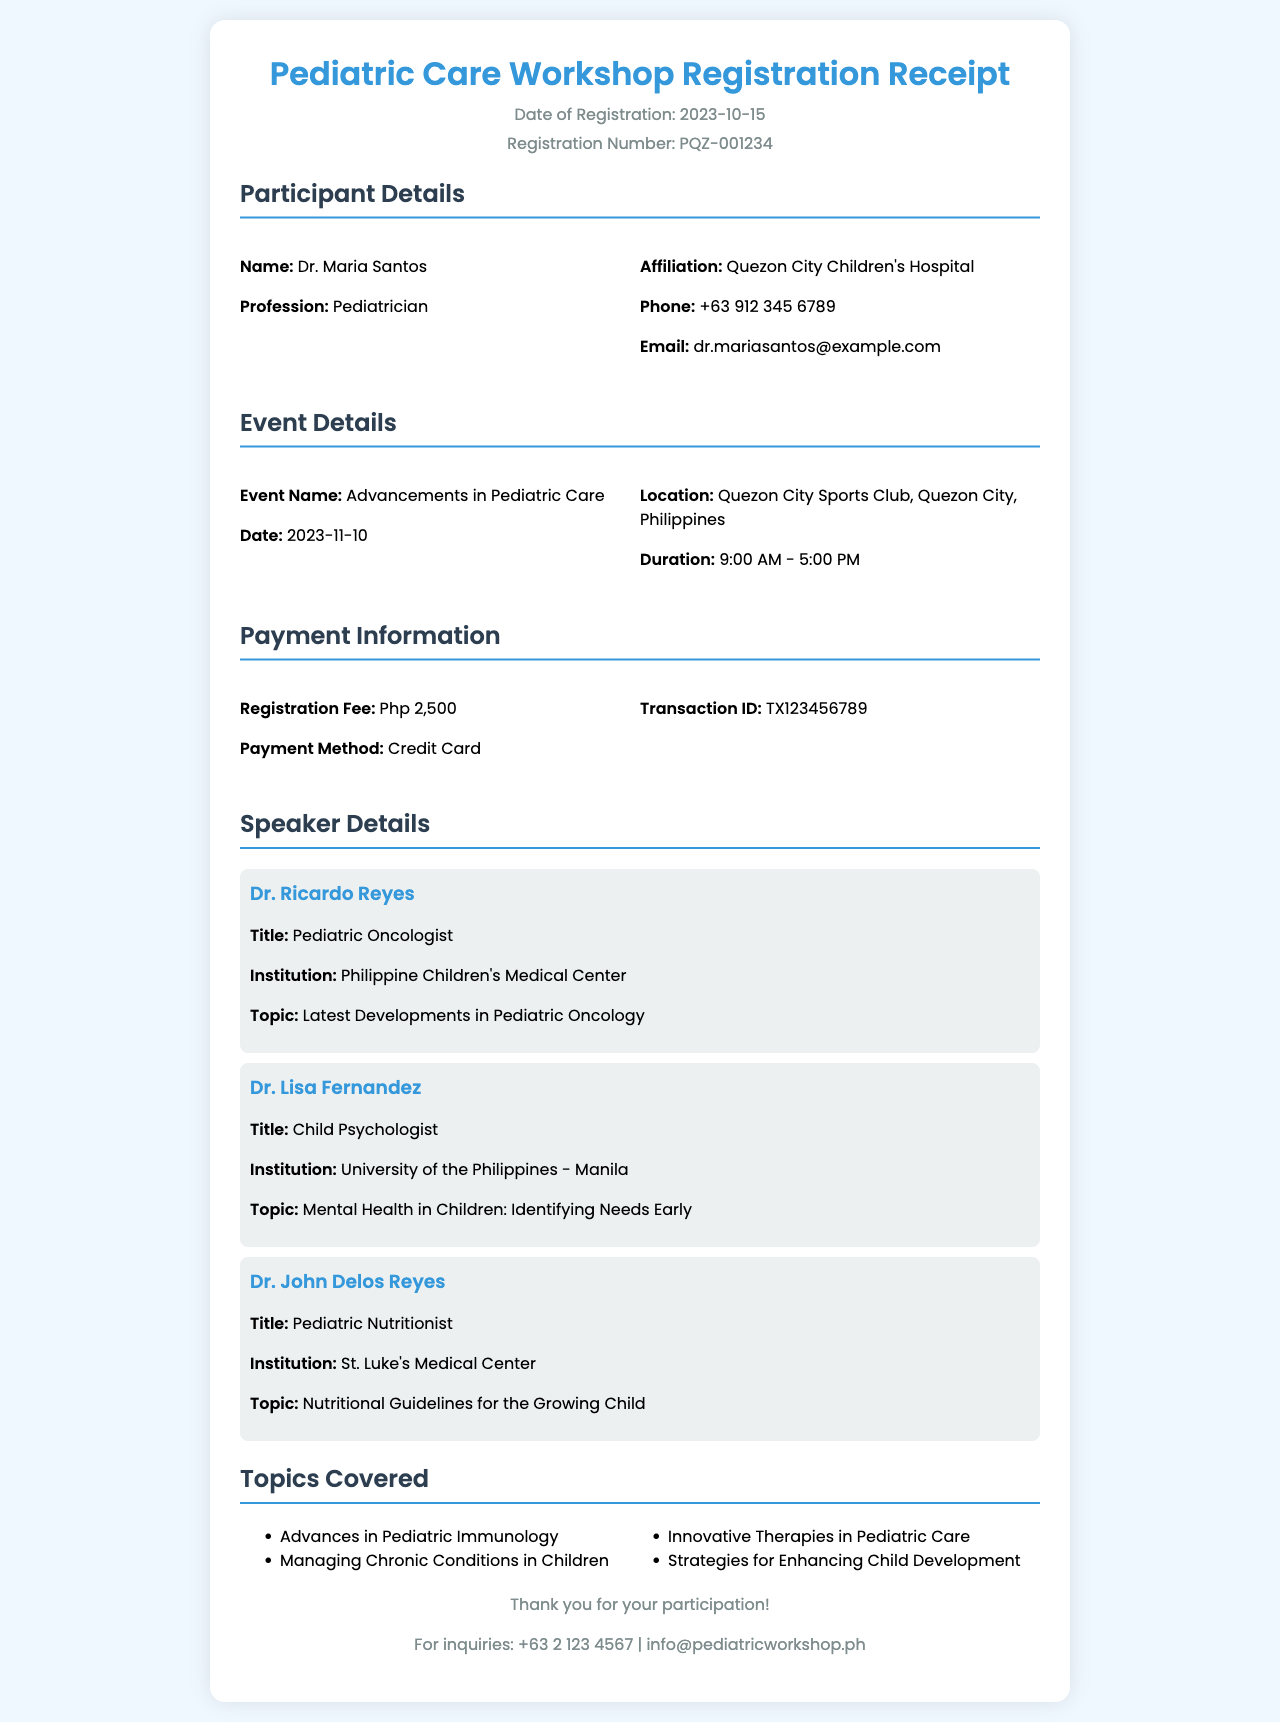what is the registration number? The registration number is provided in the header section of the receipt.
Answer: PQZ-001234 who is the participant? The participant's name can be found in the Participant Details section.
Answer: Dr. Maria Santos what is the date of the event? The date of the event is mentioned in the Event Details section.
Answer: 2023-11-10 how much is the registration fee? The registration fee is located in the Payment Information section.
Answer: Php 2,500 who is the speaker discussing pediatric oncology? The speaker details list multiple speakers; the one discussing pediatric oncology is noted.
Answer: Dr. Ricardo Reyes what is the location of the workshop? The location is specified in the Event Details section of the receipt.
Answer: Quezon City Sports Club, Quezon City, Philippines how many topics are covered in the workshop? The topics covered are listed in a bulleted format, indicating the number.
Answer: Four which institution is Dr. Lisa Fernandez affiliated with? The institution affiliation of Dr. Lisa Fernandez is provided in the Speaker Details section.
Answer: University of the Philippines - Manila what payment method was used? The payment method used is specified in the Payment Information section of the receipt.
Answer: Credit Card what is the contact number for inquiries? The contact number for inquiries is provided in the footer of the receipt.
Answer: +63 2 123 4567 